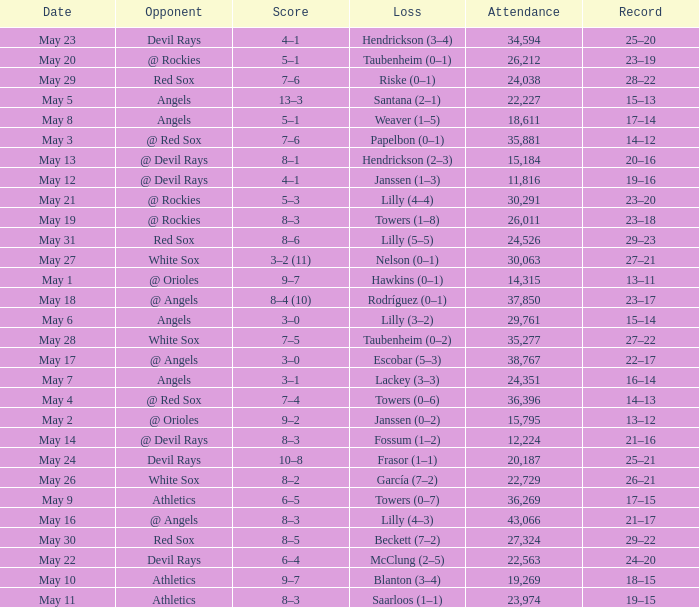Parse the table in full. {'header': ['Date', 'Opponent', 'Score', 'Loss', 'Attendance', 'Record'], 'rows': [['May 23', 'Devil Rays', '4–1', 'Hendrickson (3–4)', '34,594', '25–20'], ['May 20', '@ Rockies', '5–1', 'Taubenheim (0–1)', '26,212', '23–19'], ['May 29', 'Red Sox', '7–6', 'Riske (0–1)', '24,038', '28–22'], ['May 5', 'Angels', '13–3', 'Santana (2–1)', '22,227', '15–13'], ['May 8', 'Angels', '5–1', 'Weaver (1–5)', '18,611', '17–14'], ['May 3', '@ Red Sox', '7–6', 'Papelbon (0–1)', '35,881', '14–12'], ['May 13', '@ Devil Rays', '8–1', 'Hendrickson (2–3)', '15,184', '20–16'], ['May 12', '@ Devil Rays', '4–1', 'Janssen (1–3)', '11,816', '19–16'], ['May 21', '@ Rockies', '5–3', 'Lilly (4–4)', '30,291', '23–20'], ['May 19', '@ Rockies', '8–3', 'Towers (1–8)', '26,011', '23–18'], ['May 31', 'Red Sox', '8–6', 'Lilly (5–5)', '24,526', '29–23'], ['May 27', 'White Sox', '3–2 (11)', 'Nelson (0–1)', '30,063', '27–21'], ['May 1', '@ Orioles', '9–7', 'Hawkins (0–1)', '14,315', '13–11'], ['May 18', '@ Angels', '8–4 (10)', 'Rodríguez (0–1)', '37,850', '23–17'], ['May 6', 'Angels', '3–0', 'Lilly (3–2)', '29,761', '15–14'], ['May 28', 'White Sox', '7–5', 'Taubenheim (0–2)', '35,277', '27–22'], ['May 17', '@ Angels', '3–0', 'Escobar (5–3)', '38,767', '22–17'], ['May 7', 'Angels', '3–1', 'Lackey (3–3)', '24,351', '16–14'], ['May 4', '@ Red Sox', '7–4', 'Towers (0–6)', '36,396', '14–13'], ['May 2', '@ Orioles', '9–2', 'Janssen (0–2)', '15,795', '13–12'], ['May 14', '@ Devil Rays', '8–3', 'Fossum (1–2)', '12,224', '21–16'], ['May 24', 'Devil Rays', '10–8', 'Frasor (1–1)', '20,187', '25–21'], ['May 26', 'White Sox', '8–2', 'García (7–2)', '22,729', '26–21'], ['May 9', 'Athletics', '6–5', 'Towers (0–7)', '36,269', '17–15'], ['May 16', '@ Angels', '8–3', 'Lilly (4–3)', '43,066', '21–17'], ['May 30', 'Red Sox', '8–5', 'Beckett (7–2)', '27,324', '29–22'], ['May 22', 'Devil Rays', '6–4', 'McClung (2–5)', '22,563', '24–20'], ['May 10', 'Athletics', '9–7', 'Blanton (3–4)', '19,269', '18–15'], ['May 11', 'Athletics', '8–3', 'Saarloos (1–1)', '23,974', '19–15']]} When the team had their record of 16–14, what was the total attendance? 1.0. 